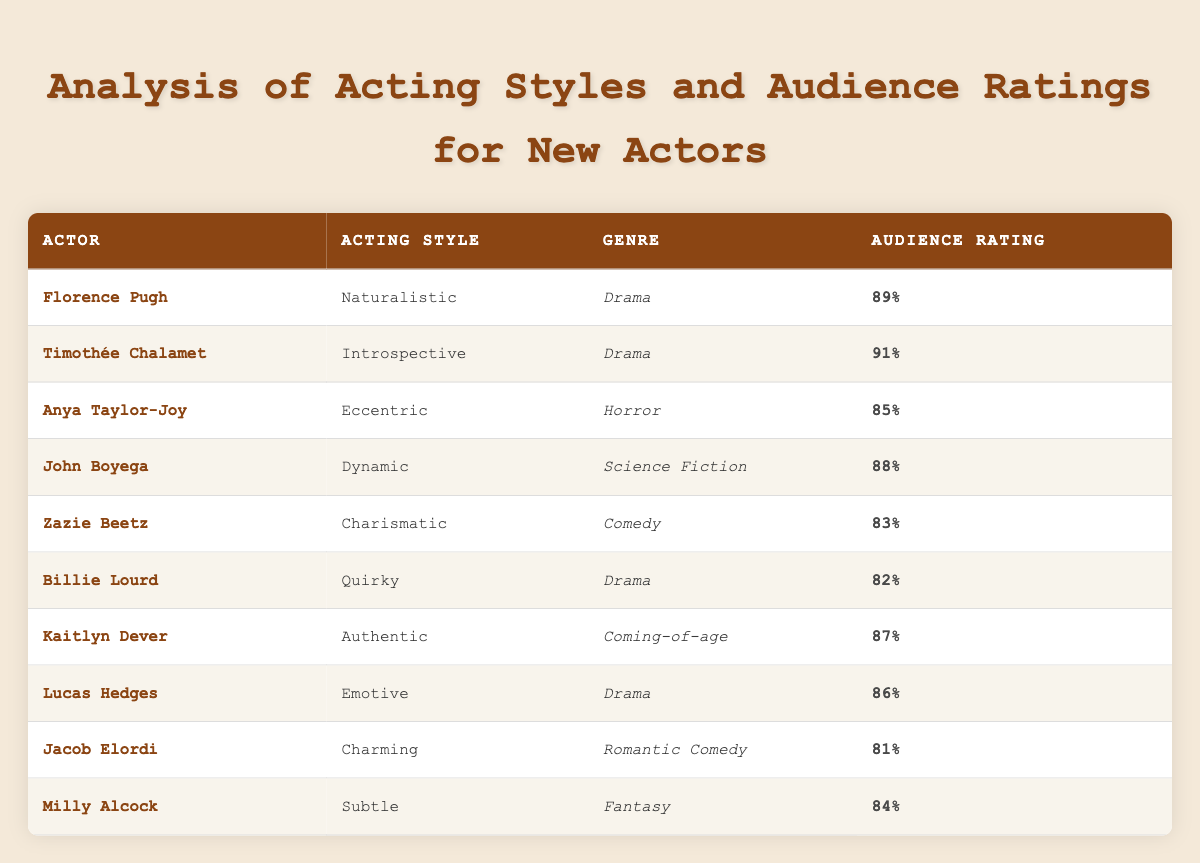What is the highest audience rating among the actors listed? The ratings in the table show Timothée Chalamet with an audience rating of 91%, which is higher than any other actor listed.
Answer: 91% Which actor has the lowest audience rating? According to the table, Jacob Elordi has the lowest audience rating at 81%, which is lower than the rest of the actors.
Answer: 81% Do all actors in the table belong to the Drama genre? No, the table indicates that there are actors from different genres, such as Horror, Science Fiction, Comedy, Coming-of-age, and Fantasy, in addition to Drama.
Answer: No What is the average audience rating for actors in the Drama genre? The audience ratings for actors in the Drama genre are 89 (Florence Pugh), 91 (Timothée Chalamet), 82 (Billie Lourd), 87 (Kaitlyn Dever), and 86 (Lucas Hedges). Adding these ratings gives a total of 435. Since there are 5 actors, the average rating is 435/5 = 87.
Answer: 87 How many actors have an acting style that is classified as "Dynamic" or "Charismatic"? Referring to the table, there is 1 actor with a "Dynamic" acting style (John Boyega) and 1 actor with a "Charismatic" acting style (Zazie Beetz). Thus, the total number of such actors is 2.
Answer: 2 Which genre has the actor with the highest rating, and what is that rating? The genre with the actor of the highest rating is Drama, where Timothée Chalamet has the highest audience rating of 91%.
Answer: Drama, 91% Is there an actor who has an audience rating above 85% in both Drama and another genre? Yes, Timothée Chalamet has an audience rating of 91% in Drama, and John Boyega has an 88% in Science Fiction, both above 85%.
Answer: Yes How does Anya Taylor-Joy's audience rating compare to those of the actors in the Comedy genre? Anya Taylor-Joy has an audience rating of 85%, while Zazie Beetz in Comedy has an audience rating of 83%. Therefore, Anya's rating is higher than Zazie’s.
Answer: Higher 